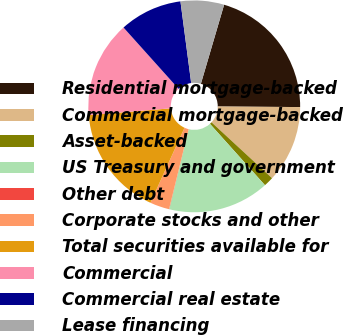<chart> <loc_0><loc_0><loc_500><loc_500><pie_chart><fcel>Residential mortgage-backed<fcel>Commercial mortgage-backed<fcel>Asset-backed<fcel>US Treasury and government<fcel>Other debt<fcel>Corporate stocks and other<fcel>Total securities available for<fcel>Commercial<fcel>Commercial real estate<fcel>Lease financing<nl><fcel>20.56%<fcel>11.76%<fcel>1.5%<fcel>15.43%<fcel>0.03%<fcel>2.96%<fcel>16.89%<fcel>14.69%<fcel>9.56%<fcel>6.63%<nl></chart> 